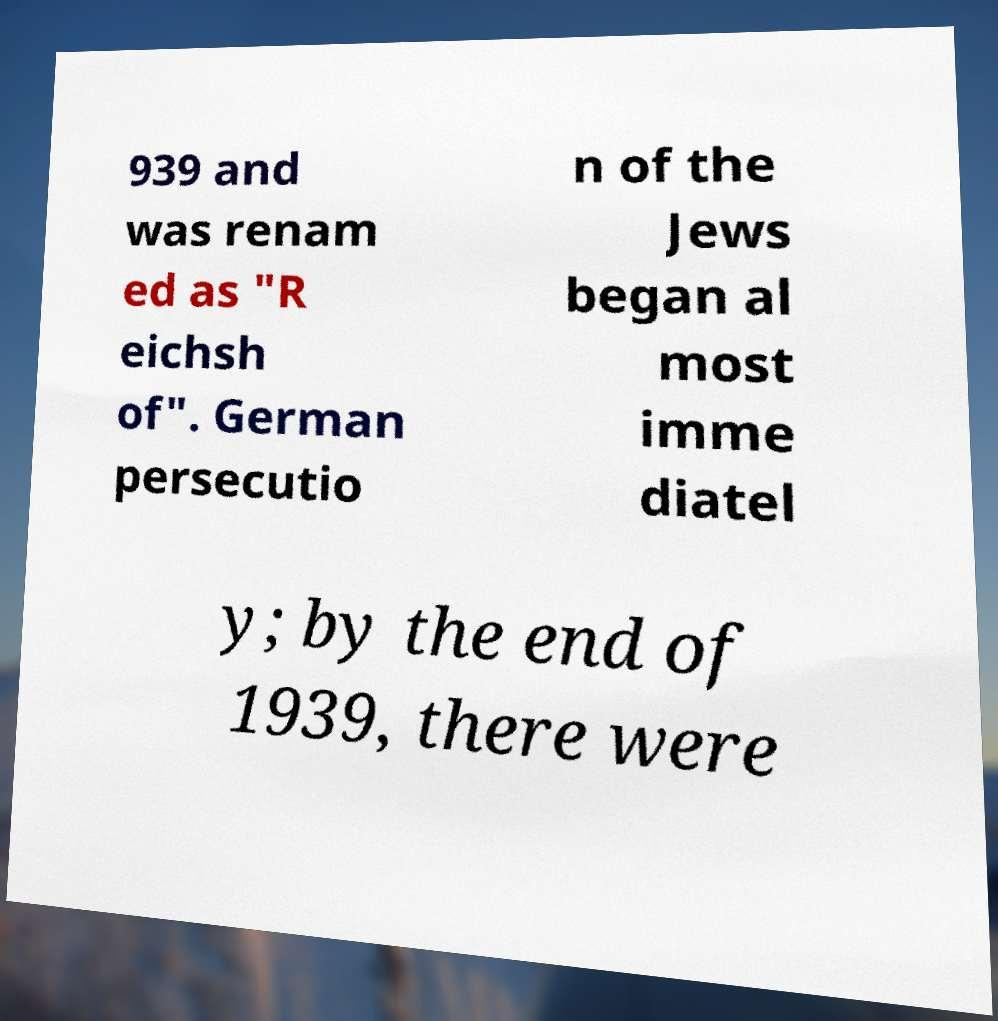Can you accurately transcribe the text from the provided image for me? 939 and was renam ed as "R eichsh of". German persecutio n of the Jews began al most imme diatel y; by the end of 1939, there were 